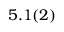<formula> <loc_0><loc_0><loc_500><loc_500>5 . 1 ( 2 )</formula> 